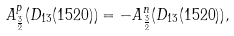<formula> <loc_0><loc_0><loc_500><loc_500>A ^ { p } _ { \frac { 3 } { 2 } } ( D _ { 1 3 } ( 1 5 2 0 ) ) = - A ^ { n } _ { \frac { 3 } { 2 } } ( D _ { 1 3 } ( 1 5 2 0 ) ) ,</formula> 